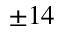Convert formula to latex. <formula><loc_0><loc_0><loc_500><loc_500>\pm 1 4</formula> 